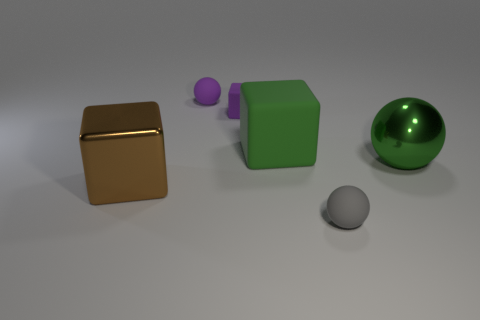How could these objects be used in a learning environment or game? These objects could be part of a learning module for children, focusing on shapes, colors, and materials. For a game, they could be elements of a puzzle where players must sort or match items based on those attributes. The different sizes and materials would also be useful for tactile exercises in sensory learning activities. 